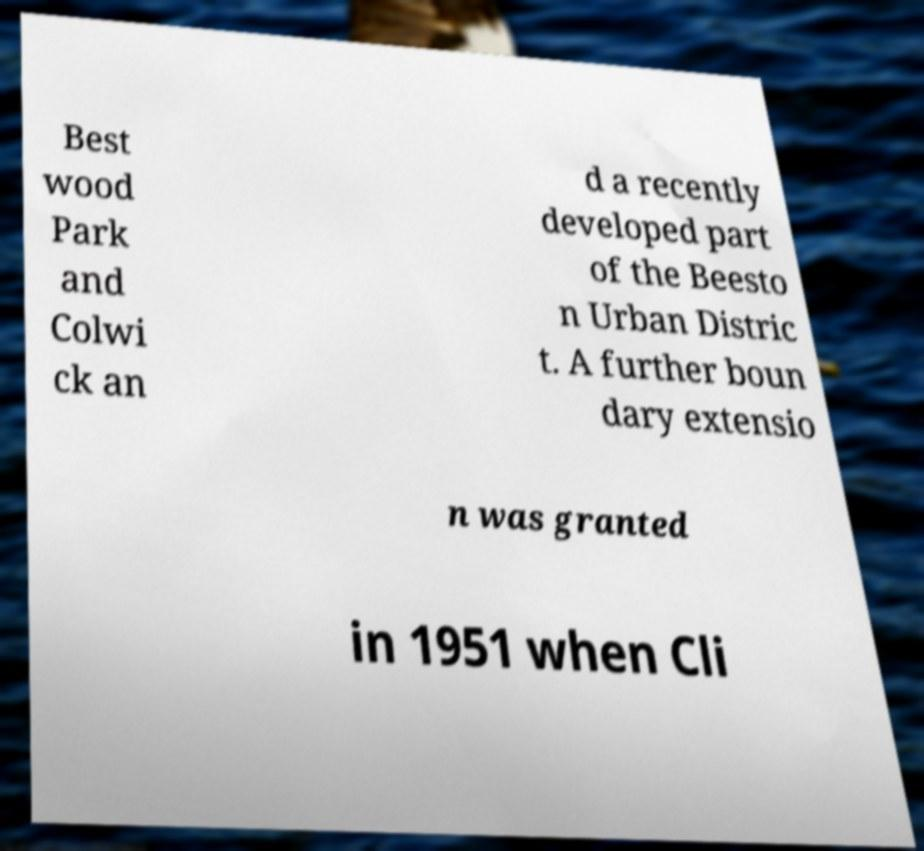Please read and relay the text visible in this image. What does it say? Best wood Park and Colwi ck an d a recently developed part of the Beesto n Urban Distric t. A further boun dary extensio n was granted in 1951 when Cli 